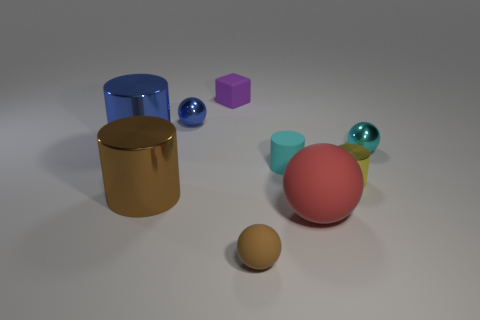Is there anything else that has the same material as the tiny yellow thing?
Your response must be concise. Yes. What is the material of the blue ball that is the same size as the yellow cylinder?
Provide a succinct answer. Metal. Are there any other large brown things that have the same shape as the large rubber thing?
Your answer should be very brief. No. There is a cylinder that is the same color as the small matte ball; what is it made of?
Offer a very short reply. Metal. There is a small metallic object that is left of the red rubber ball; what is its shape?
Provide a short and direct response. Sphere. What number of blue spheres are there?
Your answer should be compact. 1. There is a cylinder that is the same material as the purple cube; what color is it?
Make the answer very short. Cyan. How many tiny things are red objects or brown matte blocks?
Your answer should be very brief. 0. There is a cyan cylinder; how many tiny brown objects are in front of it?
Offer a terse response. 1. The other tiny rubber object that is the same shape as the red matte object is what color?
Provide a short and direct response. Brown. 